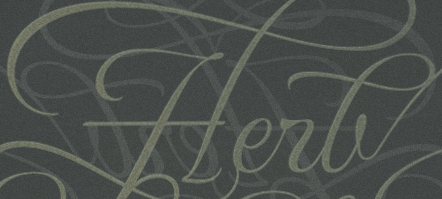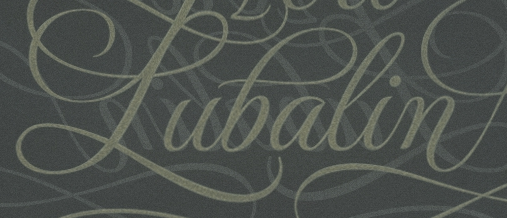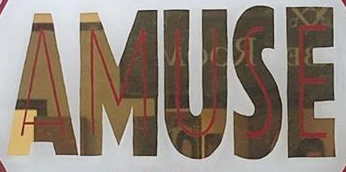Transcribe the words shown in these images in order, separated by a semicolon. Herb; Pubalin; AMUSE 